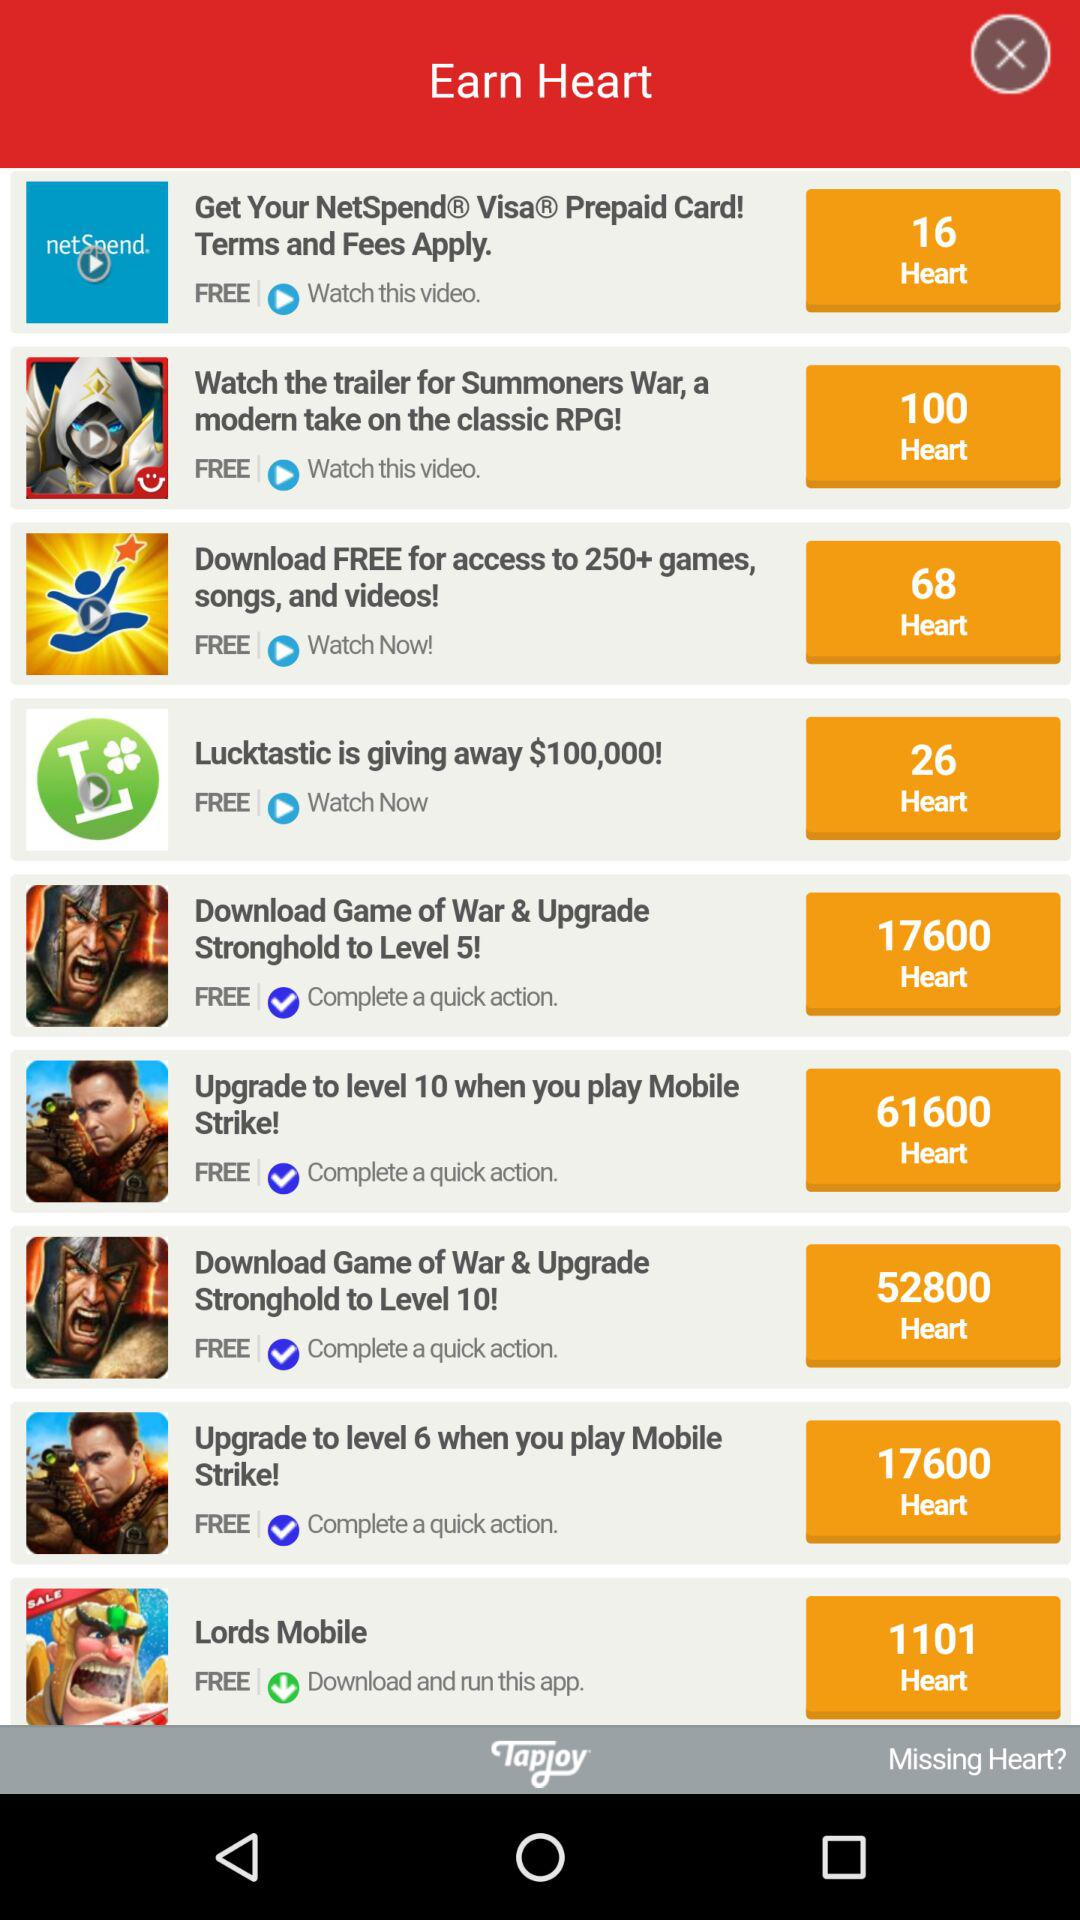How many hearts will we get for downloading and running "Lords Mobile"? You will get 1,011 hearts for downloading and running "Lords Mobile". 